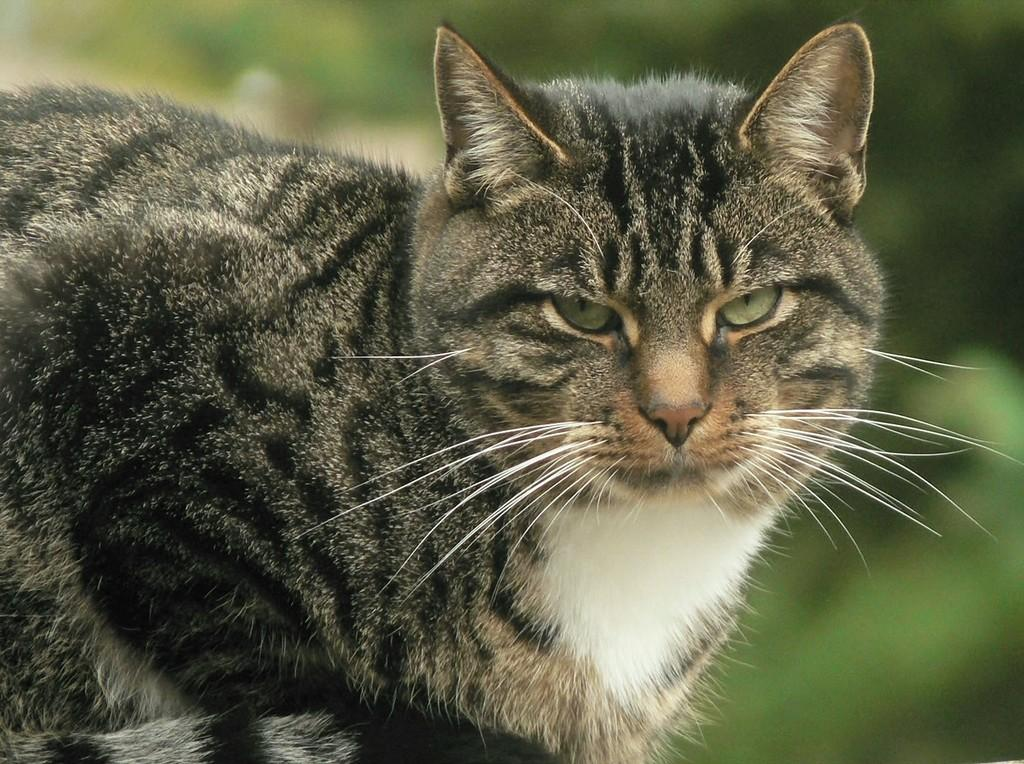What type of animal is in the image? There is a cat in the image. Can you describe the background of the image? The background of the image is blurred. What type of stew is the cat eating in the image? There is no stew present in the image; it only features a cat and a blurred background. 